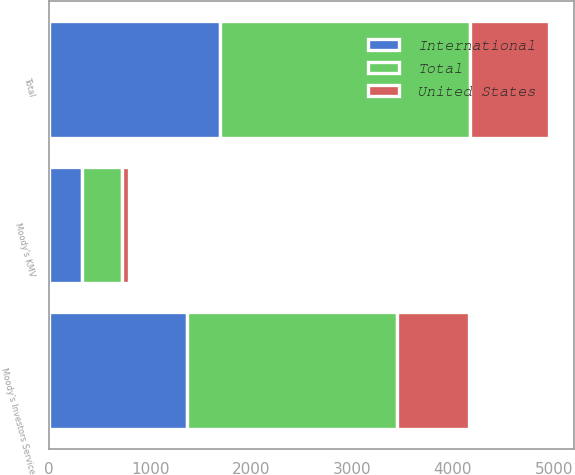Convert chart to OTSL. <chart><loc_0><loc_0><loc_500><loc_500><stacked_bar_chart><ecel><fcel>Moody's Investors Service<fcel>Moody's KMV<fcel>Total<nl><fcel>International<fcel>1364<fcel>329<fcel>1693<nl><fcel>United States<fcel>716<fcel>68<fcel>784<nl><fcel>Total<fcel>2080<fcel>397<fcel>2477<nl></chart> 